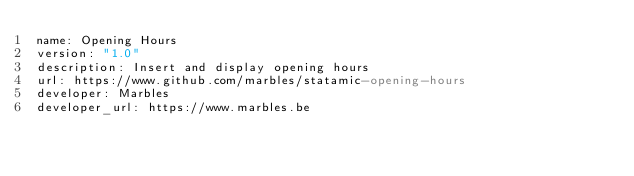<code> <loc_0><loc_0><loc_500><loc_500><_YAML_>name: Opening Hours
version: "1.0"
description: Insert and display opening hours
url: https://www.github.com/marbles/statamic-opening-hours
developer: Marbles
developer_url: https://www.marbles.be
</code> 